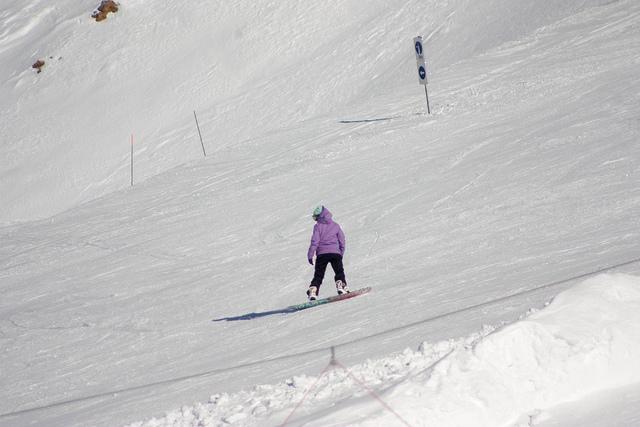Why would you assume this is a female?
Write a very short answer. Yes. Is this a man?
Keep it brief. No. What color is her coat?
Give a very brief answer. Purple. What covers the ground?
Quick response, please. Snow. 